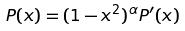<formula> <loc_0><loc_0><loc_500><loc_500>P ( x ) = ( 1 - x ^ { 2 } ) ^ { \alpha } P ^ { \prime } ( x )</formula> 